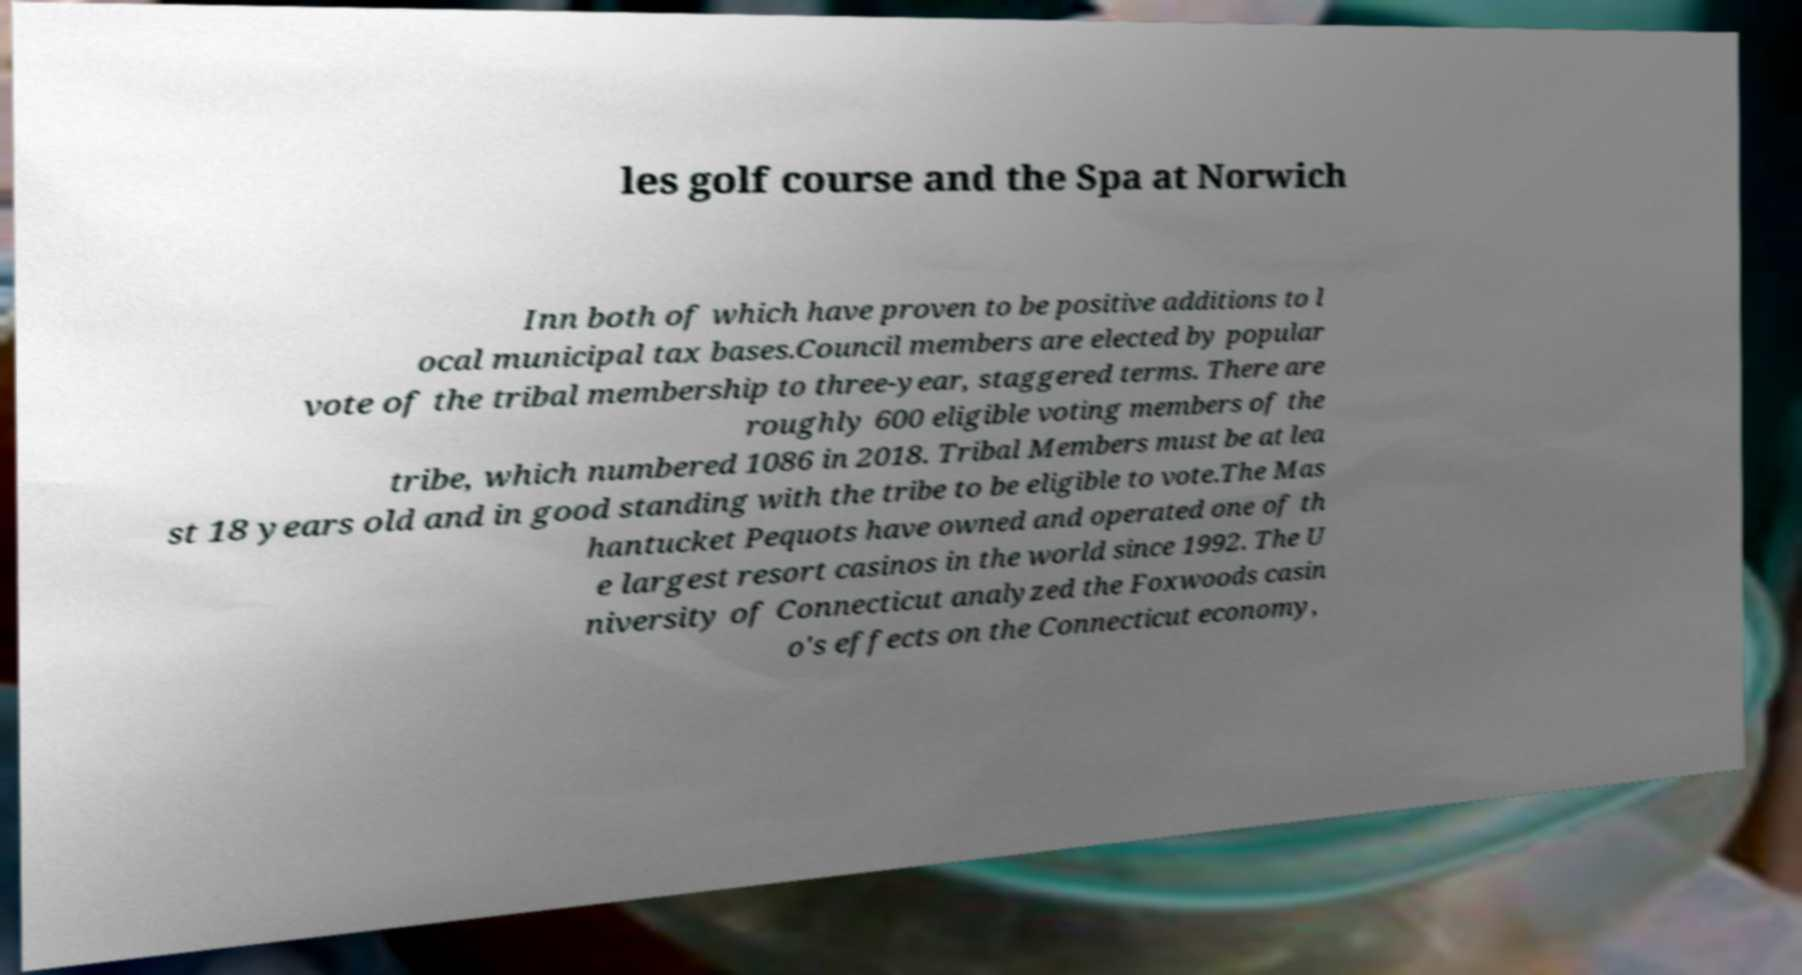Please identify and transcribe the text found in this image. les golf course and the Spa at Norwich Inn both of which have proven to be positive additions to l ocal municipal tax bases.Council members are elected by popular vote of the tribal membership to three-year, staggered terms. There are roughly 600 eligible voting members of the tribe, which numbered 1086 in 2018. Tribal Members must be at lea st 18 years old and in good standing with the tribe to be eligible to vote.The Mas hantucket Pequots have owned and operated one of th e largest resort casinos in the world since 1992. The U niversity of Connecticut analyzed the Foxwoods casin o's effects on the Connecticut economy, 